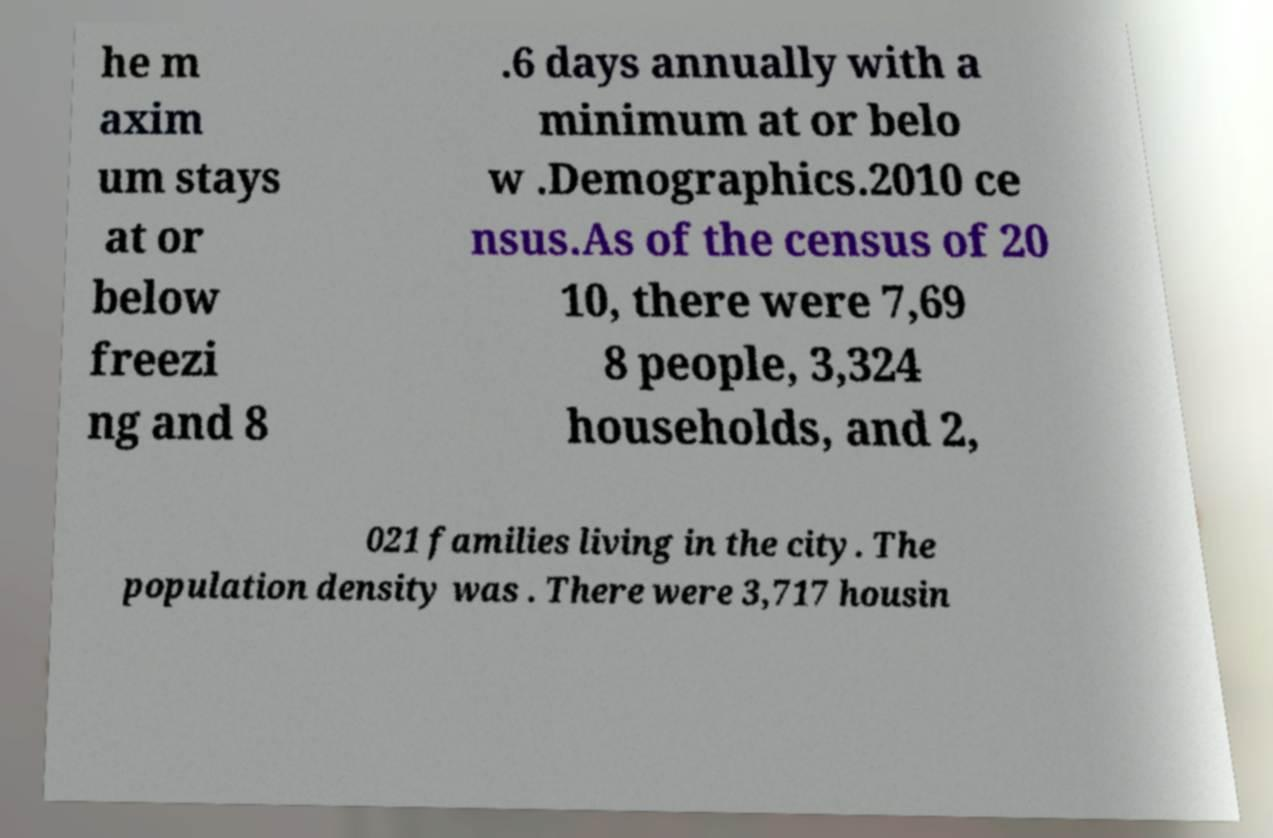Please read and relay the text visible in this image. What does it say? he m axim um stays at or below freezi ng and 8 .6 days annually with a minimum at or belo w .Demographics.2010 ce nsus.As of the census of 20 10, there were 7,69 8 people, 3,324 households, and 2, 021 families living in the city. The population density was . There were 3,717 housin 